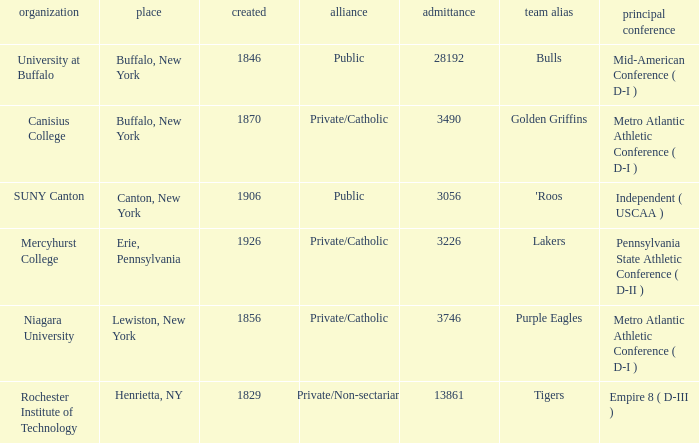What was the enrollment of the school founded in 1846? 28192.0. 